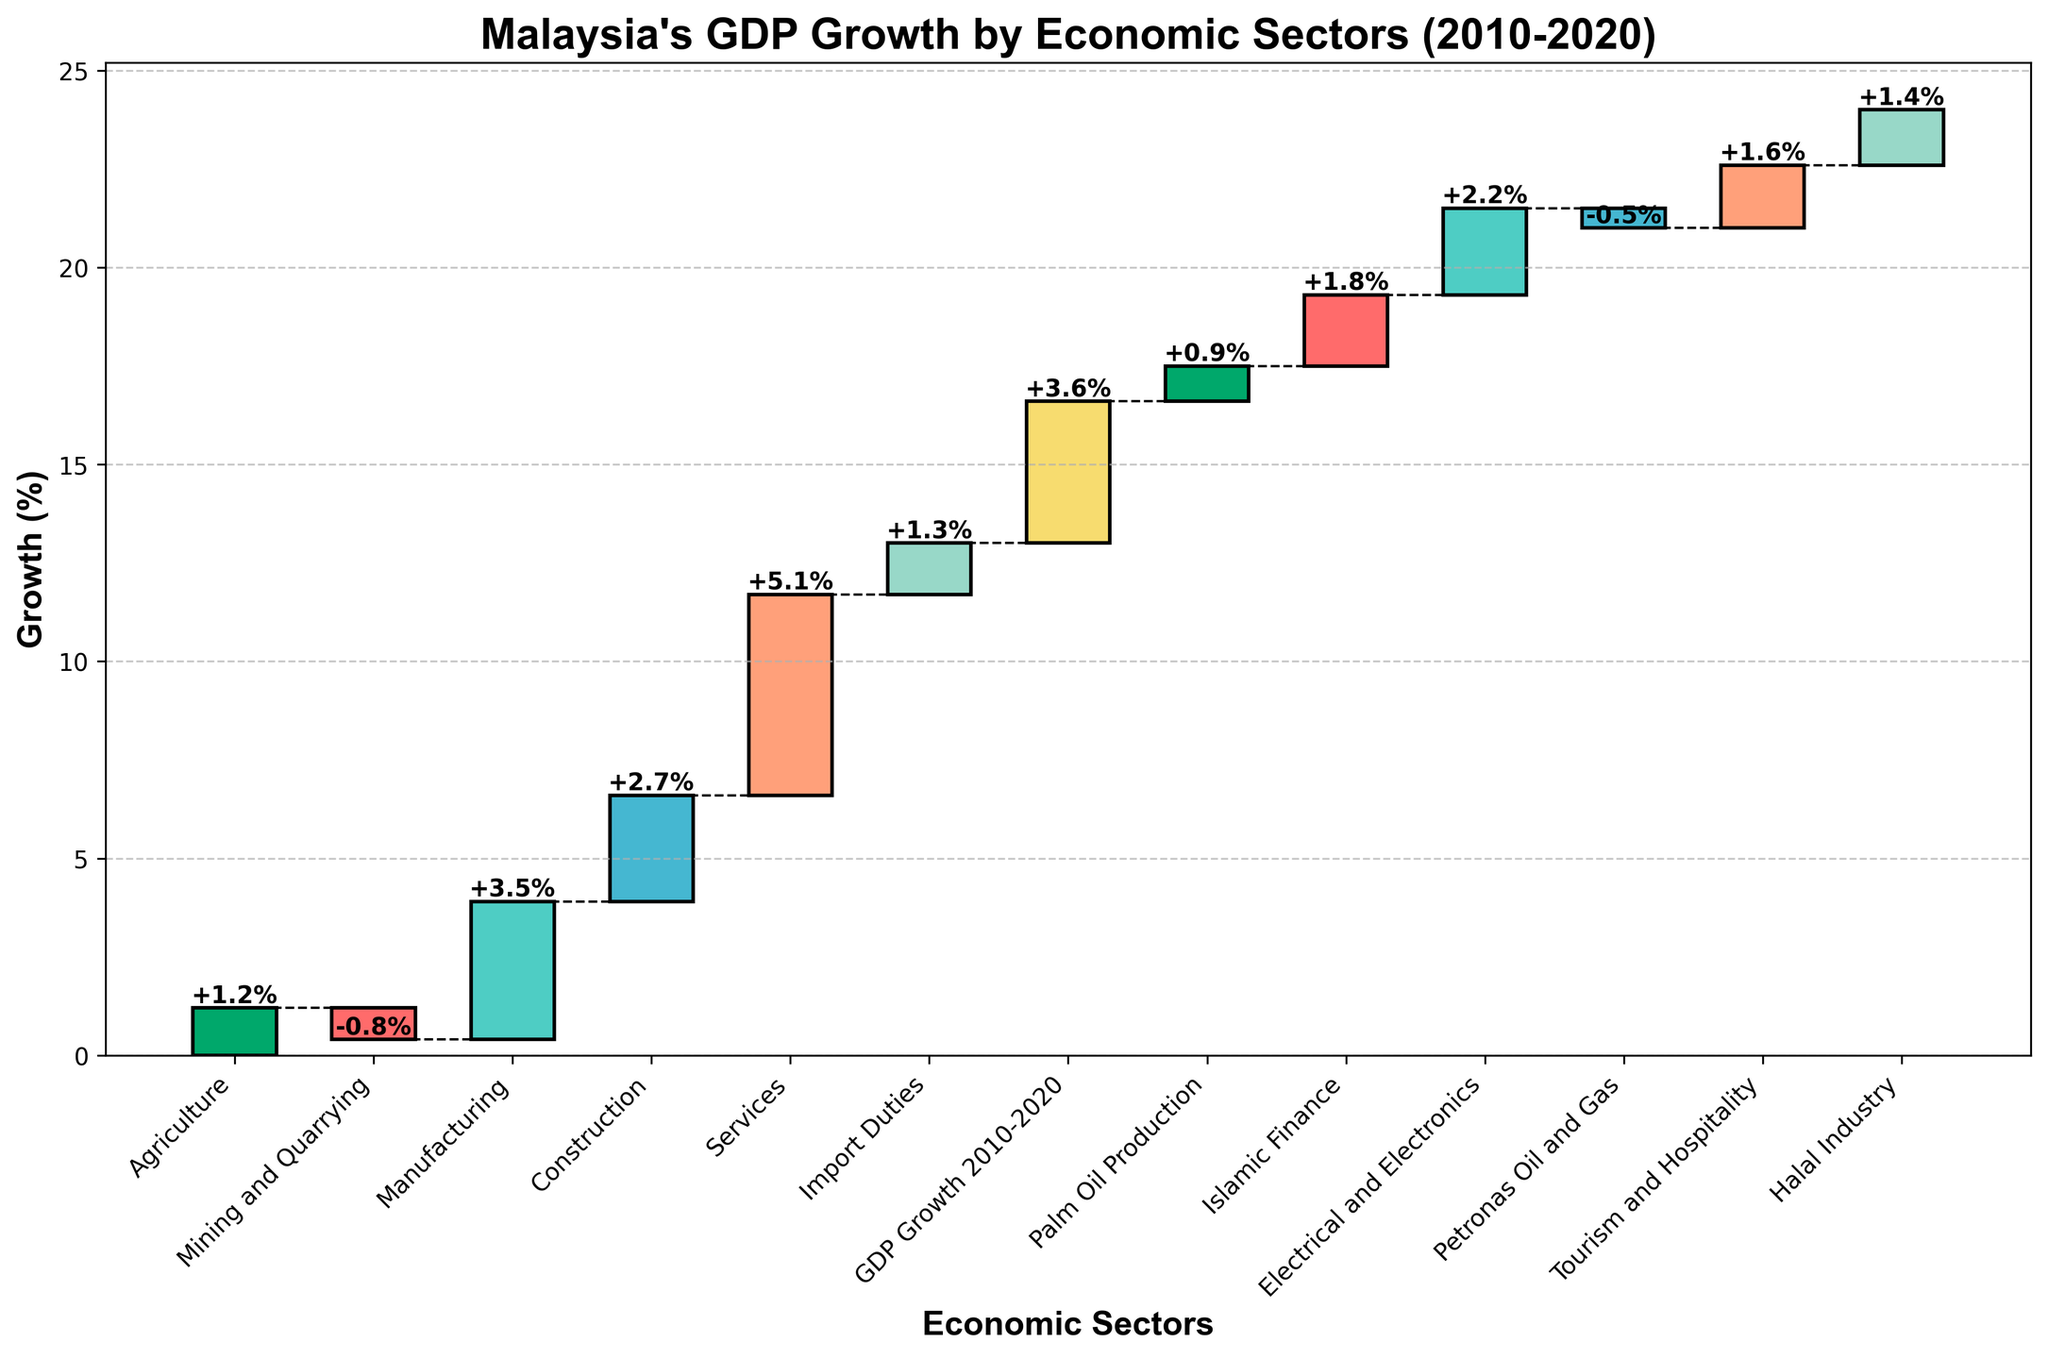What is the title of the chart? The title is displayed at the top of the chart. It is clearly written in a larger font size compared to other text, indicating it describes the contents of the chart.
Answer: Malaysia's GDP Growth by Economic Sectors (2010-2020) Which sector has the highest growth percentage? By looking at the length of the bars, the sector with the longest bar that extends upwards indicates the highest growth percentage.
Answer: Services What is the growth percentage for the Mining and Quarrying sector? Find the bar labeled "Mining and Quarrying." The value at the top of this bar indicates the growth percentage.
Answer: -0.8% How many sectors have a negative growth percentage? Identify the bars that are below the zero line, representing negative growth. Count the number of these bars.
Answer: 2 What is the overall GDP growth from 2010 to 2020? The overall GDP growth is usually highlighted separately and is often calculated cumulatively. It is represented as a separate bar or noted somewhere prominent in the chart.
Answer: 3.6% How does the growth in the Manufacturing sector compare to the Construction sector? Locate the bars for both sectors. Compare their heights or the values at the tops of the bars to determine which is higher or if they are equal.
Answer: Manufacturing is higher (3.5% vs. 2.7%) Which economic sector had the lowest growth? Identify the bar that extends the least, or furthest downward if negative, to find the sector with the lowest growth.
Answer: Mining and Quarrying What is the combined growth of the Agriculture, Tourism and Hospitality, and Halal Industry sectors? Sum the growth percentages of the specified sectors. Agriculture is 1.2%, Tourism and Hospitality is 1.6%, and Halal Industry is 1.4%. Summing these: 1.2 + 1.6 + 1.4 = 4.2%
Answer: 4.2% What is the impact of Palm Oil Production on Malaysia's GDP growth? Locate the bar labeled "Palm Oil Production" and note its growth percentage as its contribution to the overall GDP.
Answer: 0.9% Are there more sectors with positive or negative growth? Count the number of bars above the zero line for positive growth and the number below the zero line for negative growth. Compare the two counts.
Answer: More sectors have positive growth 